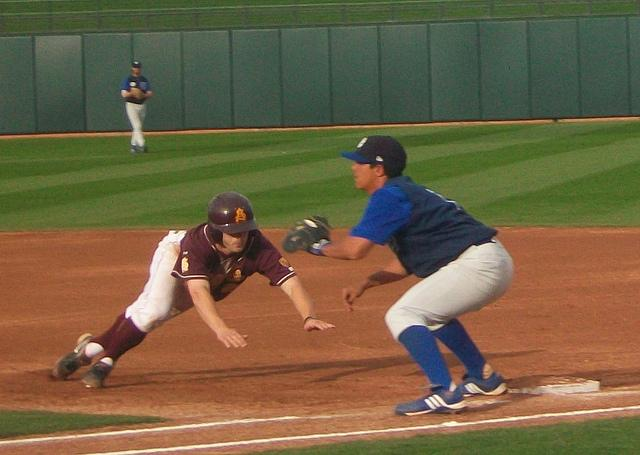What shapes are in the grass?

Choices:
A) letters
B) numbers
C) circled
D) stripes circled 